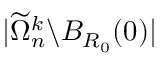<formula> <loc_0><loc_0><loc_500><loc_500>| \widetilde { \Omega } _ { n } ^ { k } \ B _ { R _ { 0 } } ( 0 ) |</formula> 